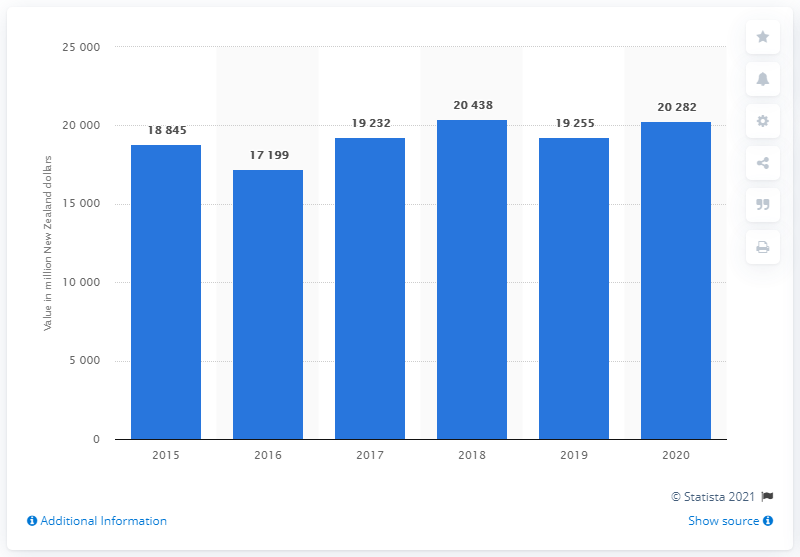Give some essential details in this illustration. In 2020, the sales revenue of Fonterra in New Zealand dollars was approximately 20,282. In 2015, the sales revenue of Fonterra in New Zealand dollars was 18,845. 